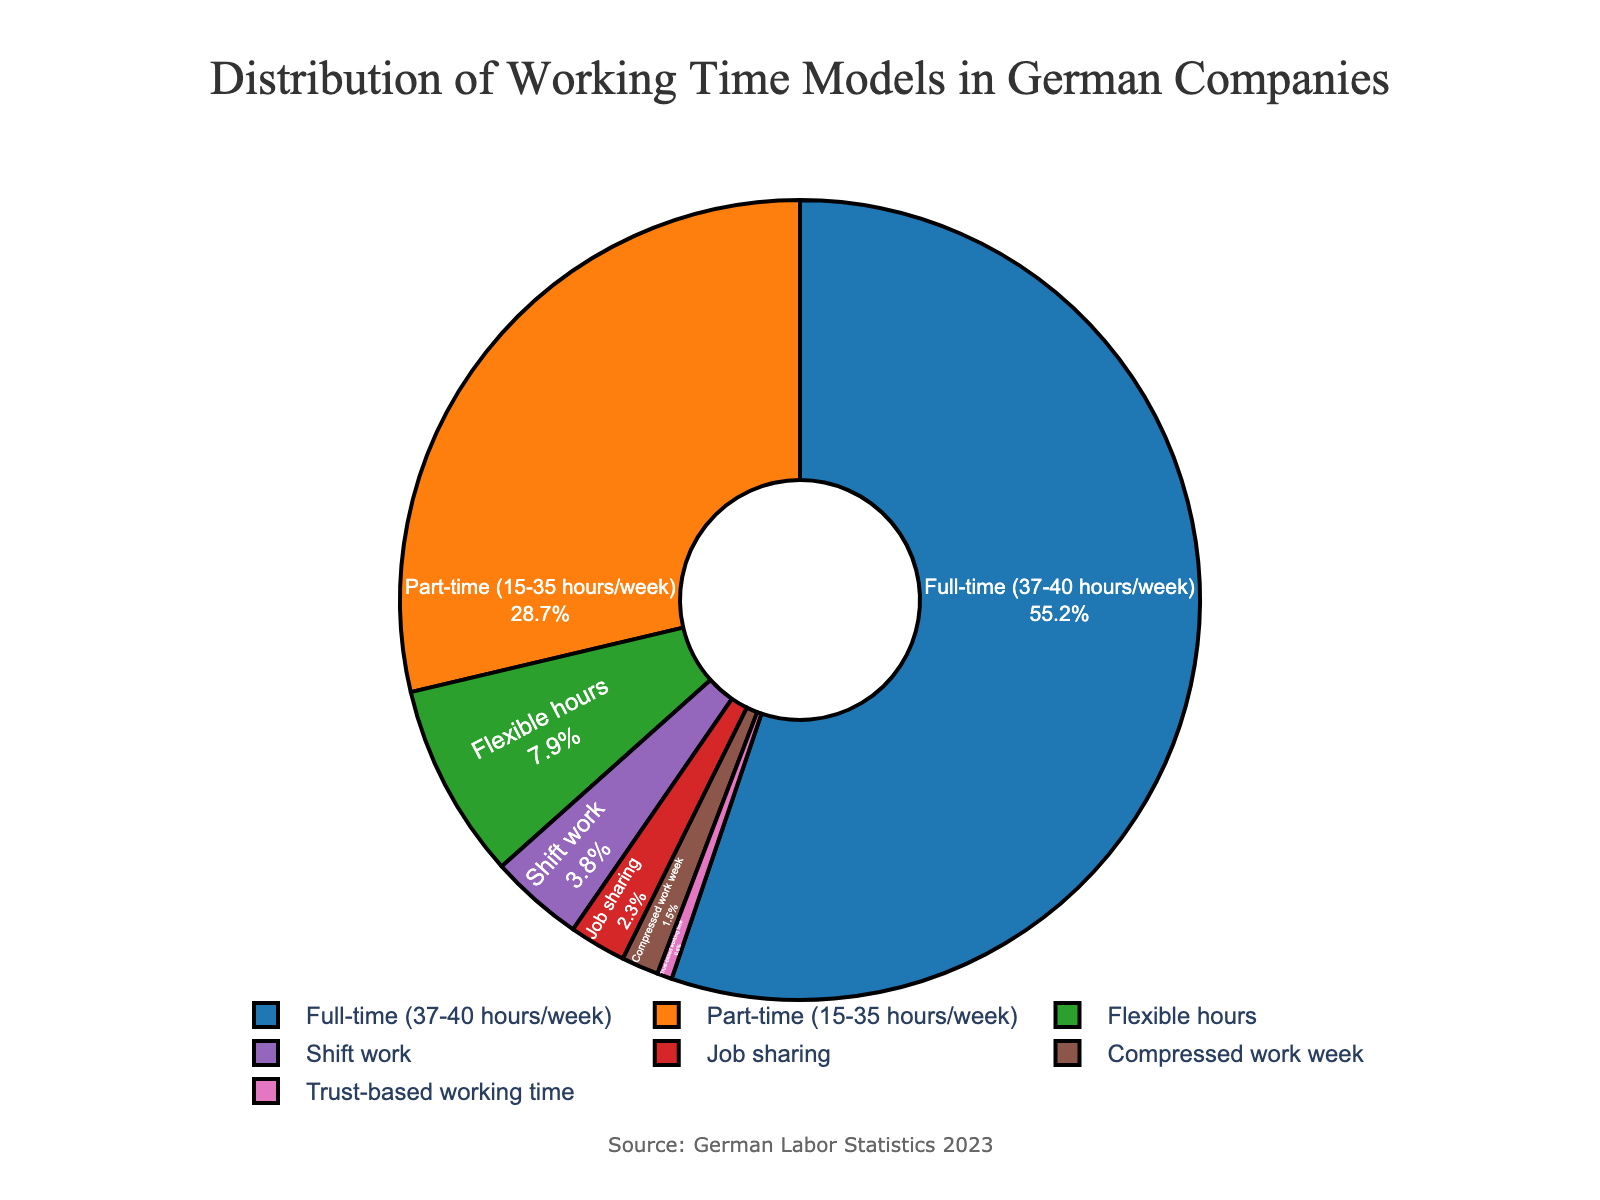What is the percentage of employees working part-time? The pie chart includes a data label for each working time model, indicating both the name and the percentage of employees. According to the chart, the percentage of employees working part-time is labeled as 28.7%.
Answer: 28.7% Which working time model has the lowest percentage? To find the working time model with the lowest percentage, we review all labeled percentages on the chart. The "Trust-based working time" has the smallest value at 0.6%.
Answer: Trust-based working time What is the difference in percentage between full-time and part-time working models? To find the difference, identify the percentages for full-time (55.2%) and part-time (28.7%) from the chart, and subtract the part-time percentage from the full-time percentage. 55.2% - 28.7% = 26.5%.
Answer: 26.5% How does the compressed work week compare to shift work in terms of percentage? By comparing the labeled percentages, the compressed work week is at 1.5% and shift work is at 3.8%, so shift work has a higher percentage.
Answer: Shift work is higher What is the combined percentage of flexible hours and job sharing? Sum the percentages of flexible hours (7.9%) and job sharing (2.3%) by adding them together: 7.9% + 2.3% = 10.2%.
Answer: 10.2% Which segment is represented by the red color and what is its percentage? From the color code provided, find the segment that corresponds to the red color. This is "Job sharing" at 2.3%.
Answer: Job sharing, 2.3% Are there more employees working full-time or using flexible hours? The percentage of employees working full-time is 55.2%, and those using flexible hours is 7.9%. Since 55.2% is greater than 7.9%, more employees are working full-time.
Answer: Full-time How many working time models have a percentage greater than 5%? From the chart, identify and count the working time models with percentages greater than 5%: Full-time (55.2%), Part-time (28.7%), and Flexible hours (7.9%). This sums to three models.
Answer: 3 What percentage of working time models are either flexible hours or trust-based working time? Sum the percentages for flexible hours (7.9%) and trust-based working time (0.6%) by adding them together: 7.9% + 0.6% = 8.5%.
Answer: 8.5% Which working time model has the third highest percentage? Rank the percentages from highest to lowest: Full-time (55.2%), Part-time (28.7%), and Flexible hours (7.9%). The third highest is Flexible hours at 7.9%.
Answer: Flexible hours 